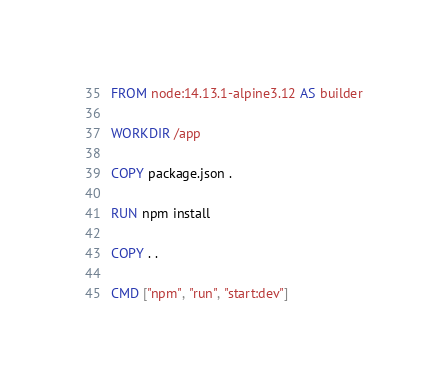<code> <loc_0><loc_0><loc_500><loc_500><_Dockerfile_>FROM node:14.13.1-alpine3.12 AS builder

WORKDIR /app

COPY package.json .

RUN npm install

COPY . .

CMD ["npm", "run", "start:dev"]</code> 